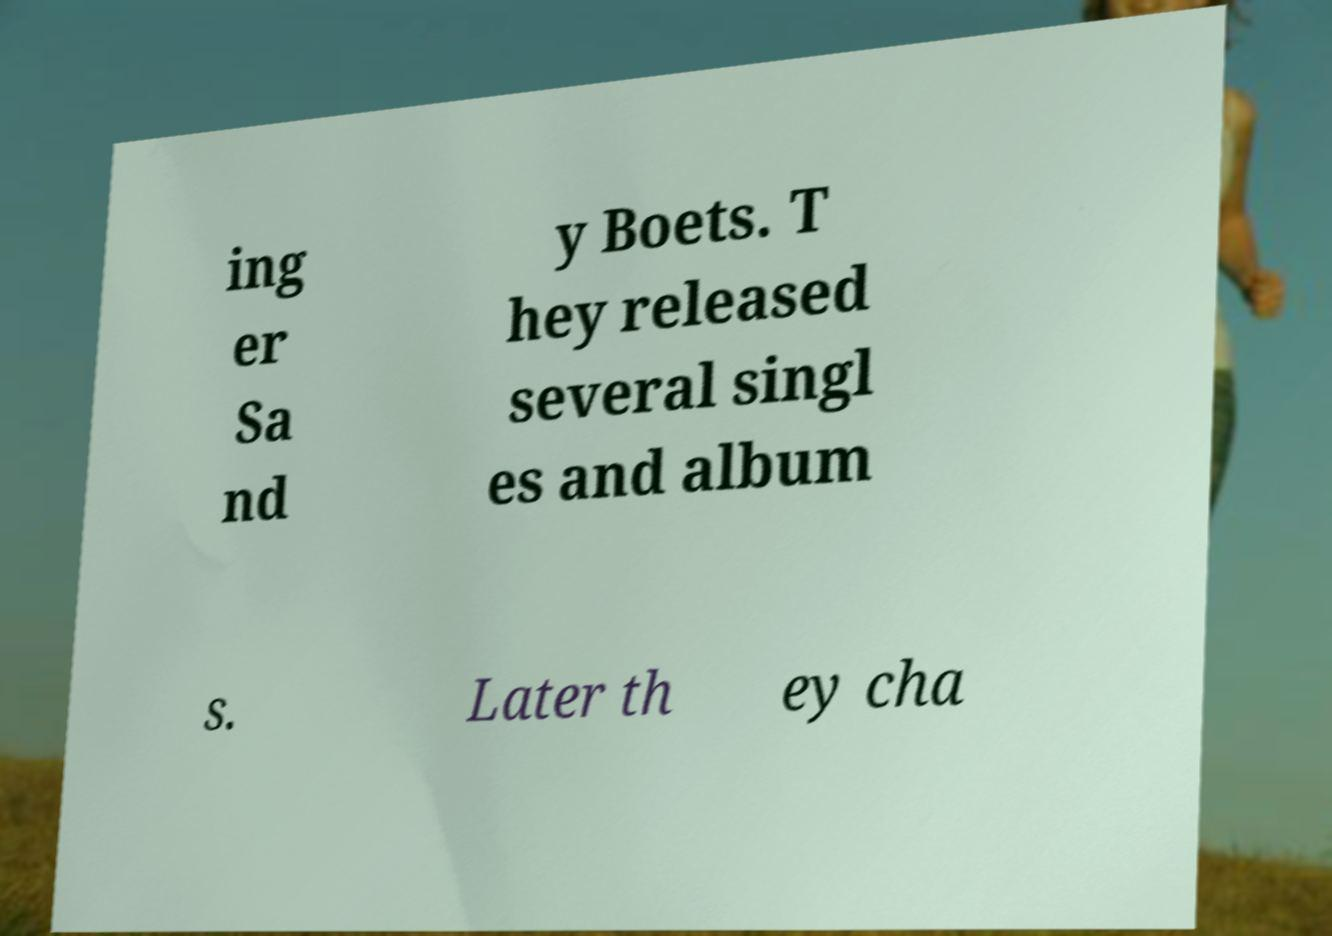For documentation purposes, I need the text within this image transcribed. Could you provide that? ing er Sa nd y Boets. T hey released several singl es and album s. Later th ey cha 